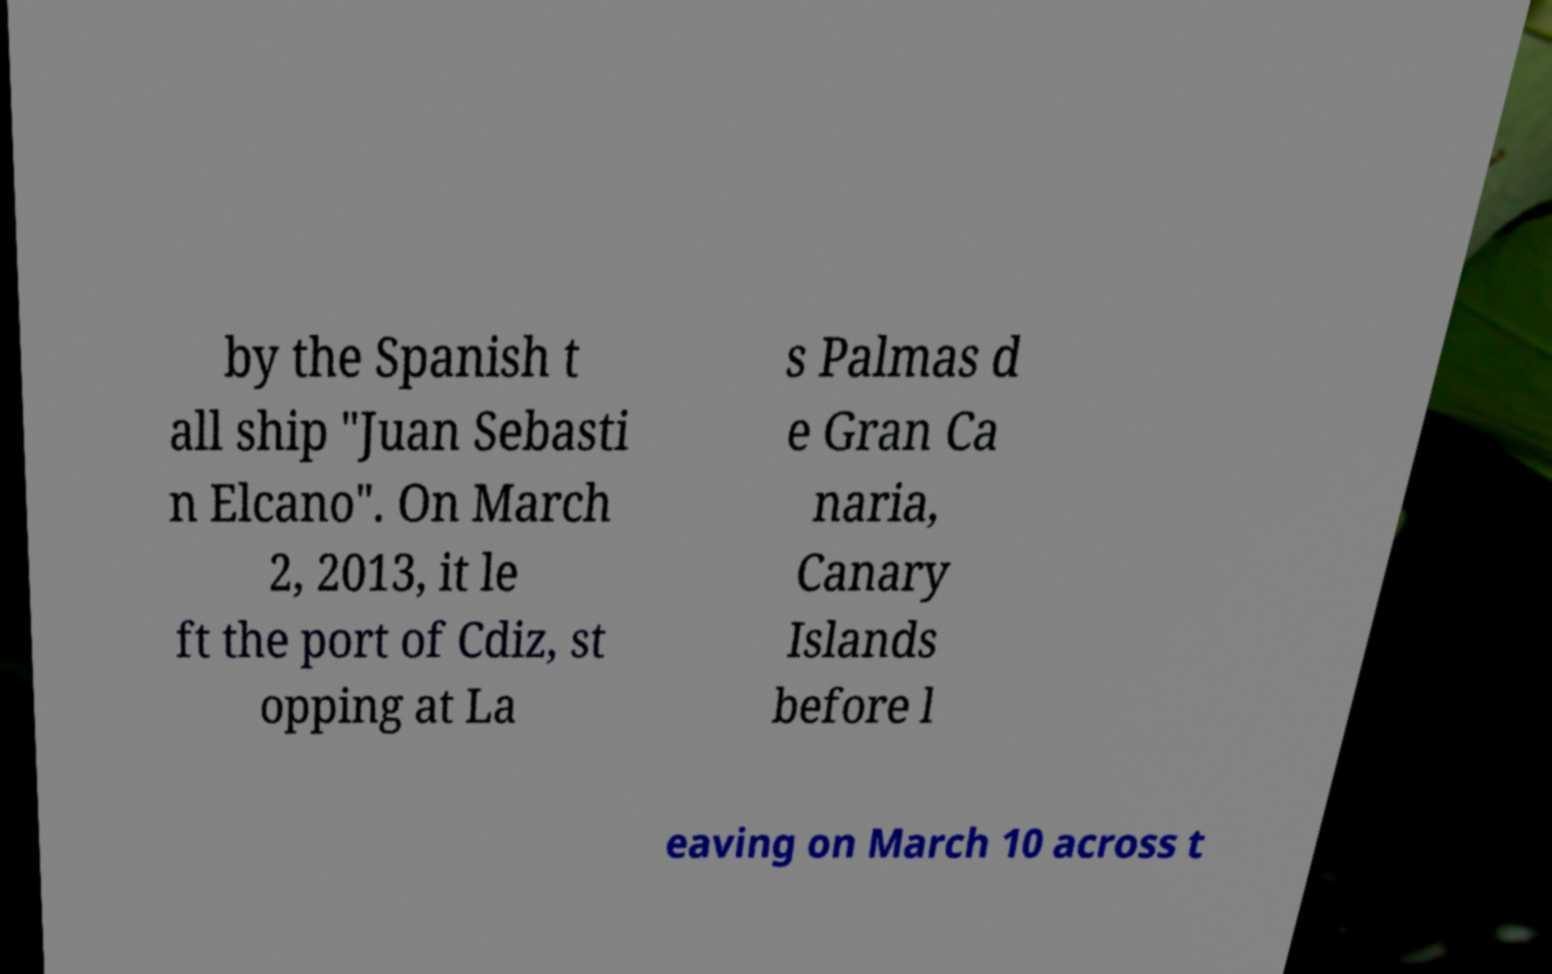Could you assist in decoding the text presented in this image and type it out clearly? by the Spanish t all ship "Juan Sebasti n Elcano". On March 2, 2013, it le ft the port of Cdiz, st opping at La s Palmas d e Gran Ca naria, Canary Islands before l eaving on March 10 across t 